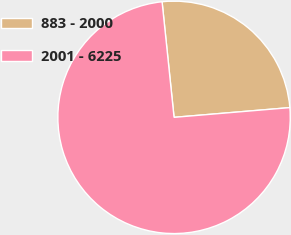<chart> <loc_0><loc_0><loc_500><loc_500><pie_chart><fcel>883 - 2000<fcel>2001 - 6225<nl><fcel>25.31%<fcel>74.69%<nl></chart> 